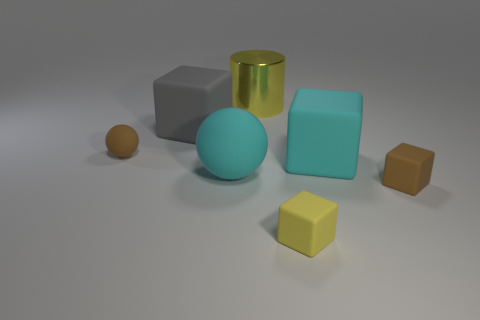Subtract all yellow matte cubes. How many cubes are left? 3 Add 1 small brown objects. How many objects exist? 8 Subtract all cubes. How many objects are left? 3 Subtract all brown cylinders. Subtract all green cubes. How many cylinders are left? 1 Subtract all brown spheres. How many spheres are left? 1 Subtract all large cylinders. Subtract all tiny cyan matte balls. How many objects are left? 6 Add 3 brown matte objects. How many brown matte objects are left? 5 Add 5 cyan objects. How many cyan objects exist? 7 Subtract 0 red cylinders. How many objects are left? 7 